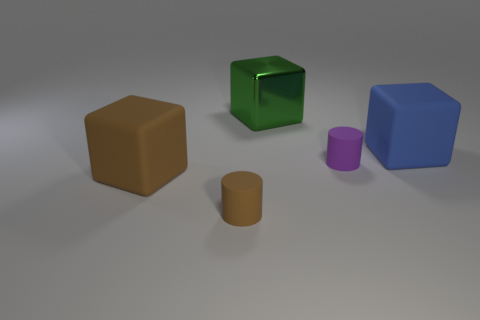What could be the potential use of these objects in a real-world setting? These objects resemble children's toy blocks, so in a real-world setting, they could be used for educational purposes such as teaching about shapes, colors, and sizes, or simply for play, helping to develop motor skills and spatial awareness in young children. 